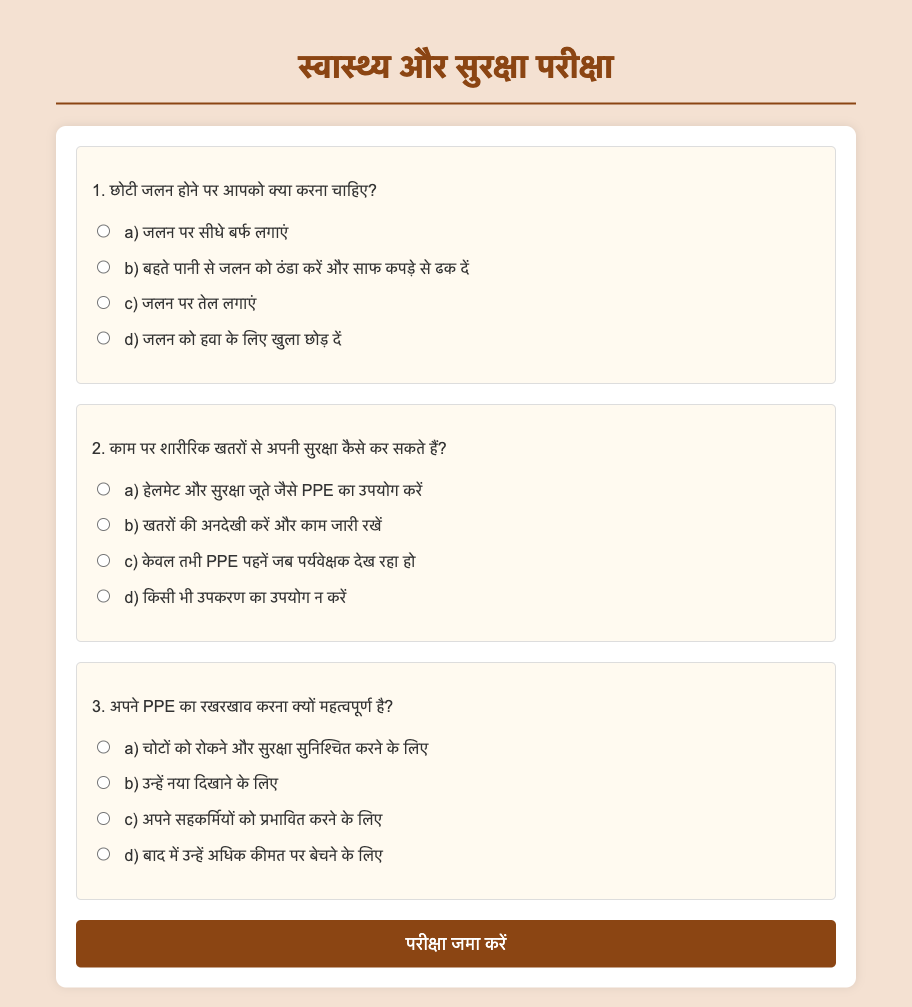what should you do for a small burn? The document suggests cooling the burn under running water and covering it with a clean cloth, not applying ice or oil.
Answer: cool under running water and cover with a clean cloth how can you protect yourself from physical hazards at work? The document indicates using PPE like helmets and safety shoes to protect against physical hazards.
Answer: use PPE like helmets and safety shoes why is maintaining your PPE important? The document states that it is important to prevent injuries and ensure safety, emphasizing the significance of PPE maintenance.
Answer: to prevent injuries and ensure safety how many main questions are included in the exam? The document contains three main questions related to health and safety practices.
Answer: three what color is the background of the exam document? The document’s background is light brown, which is the specified color for the body.
Answer: light brown 